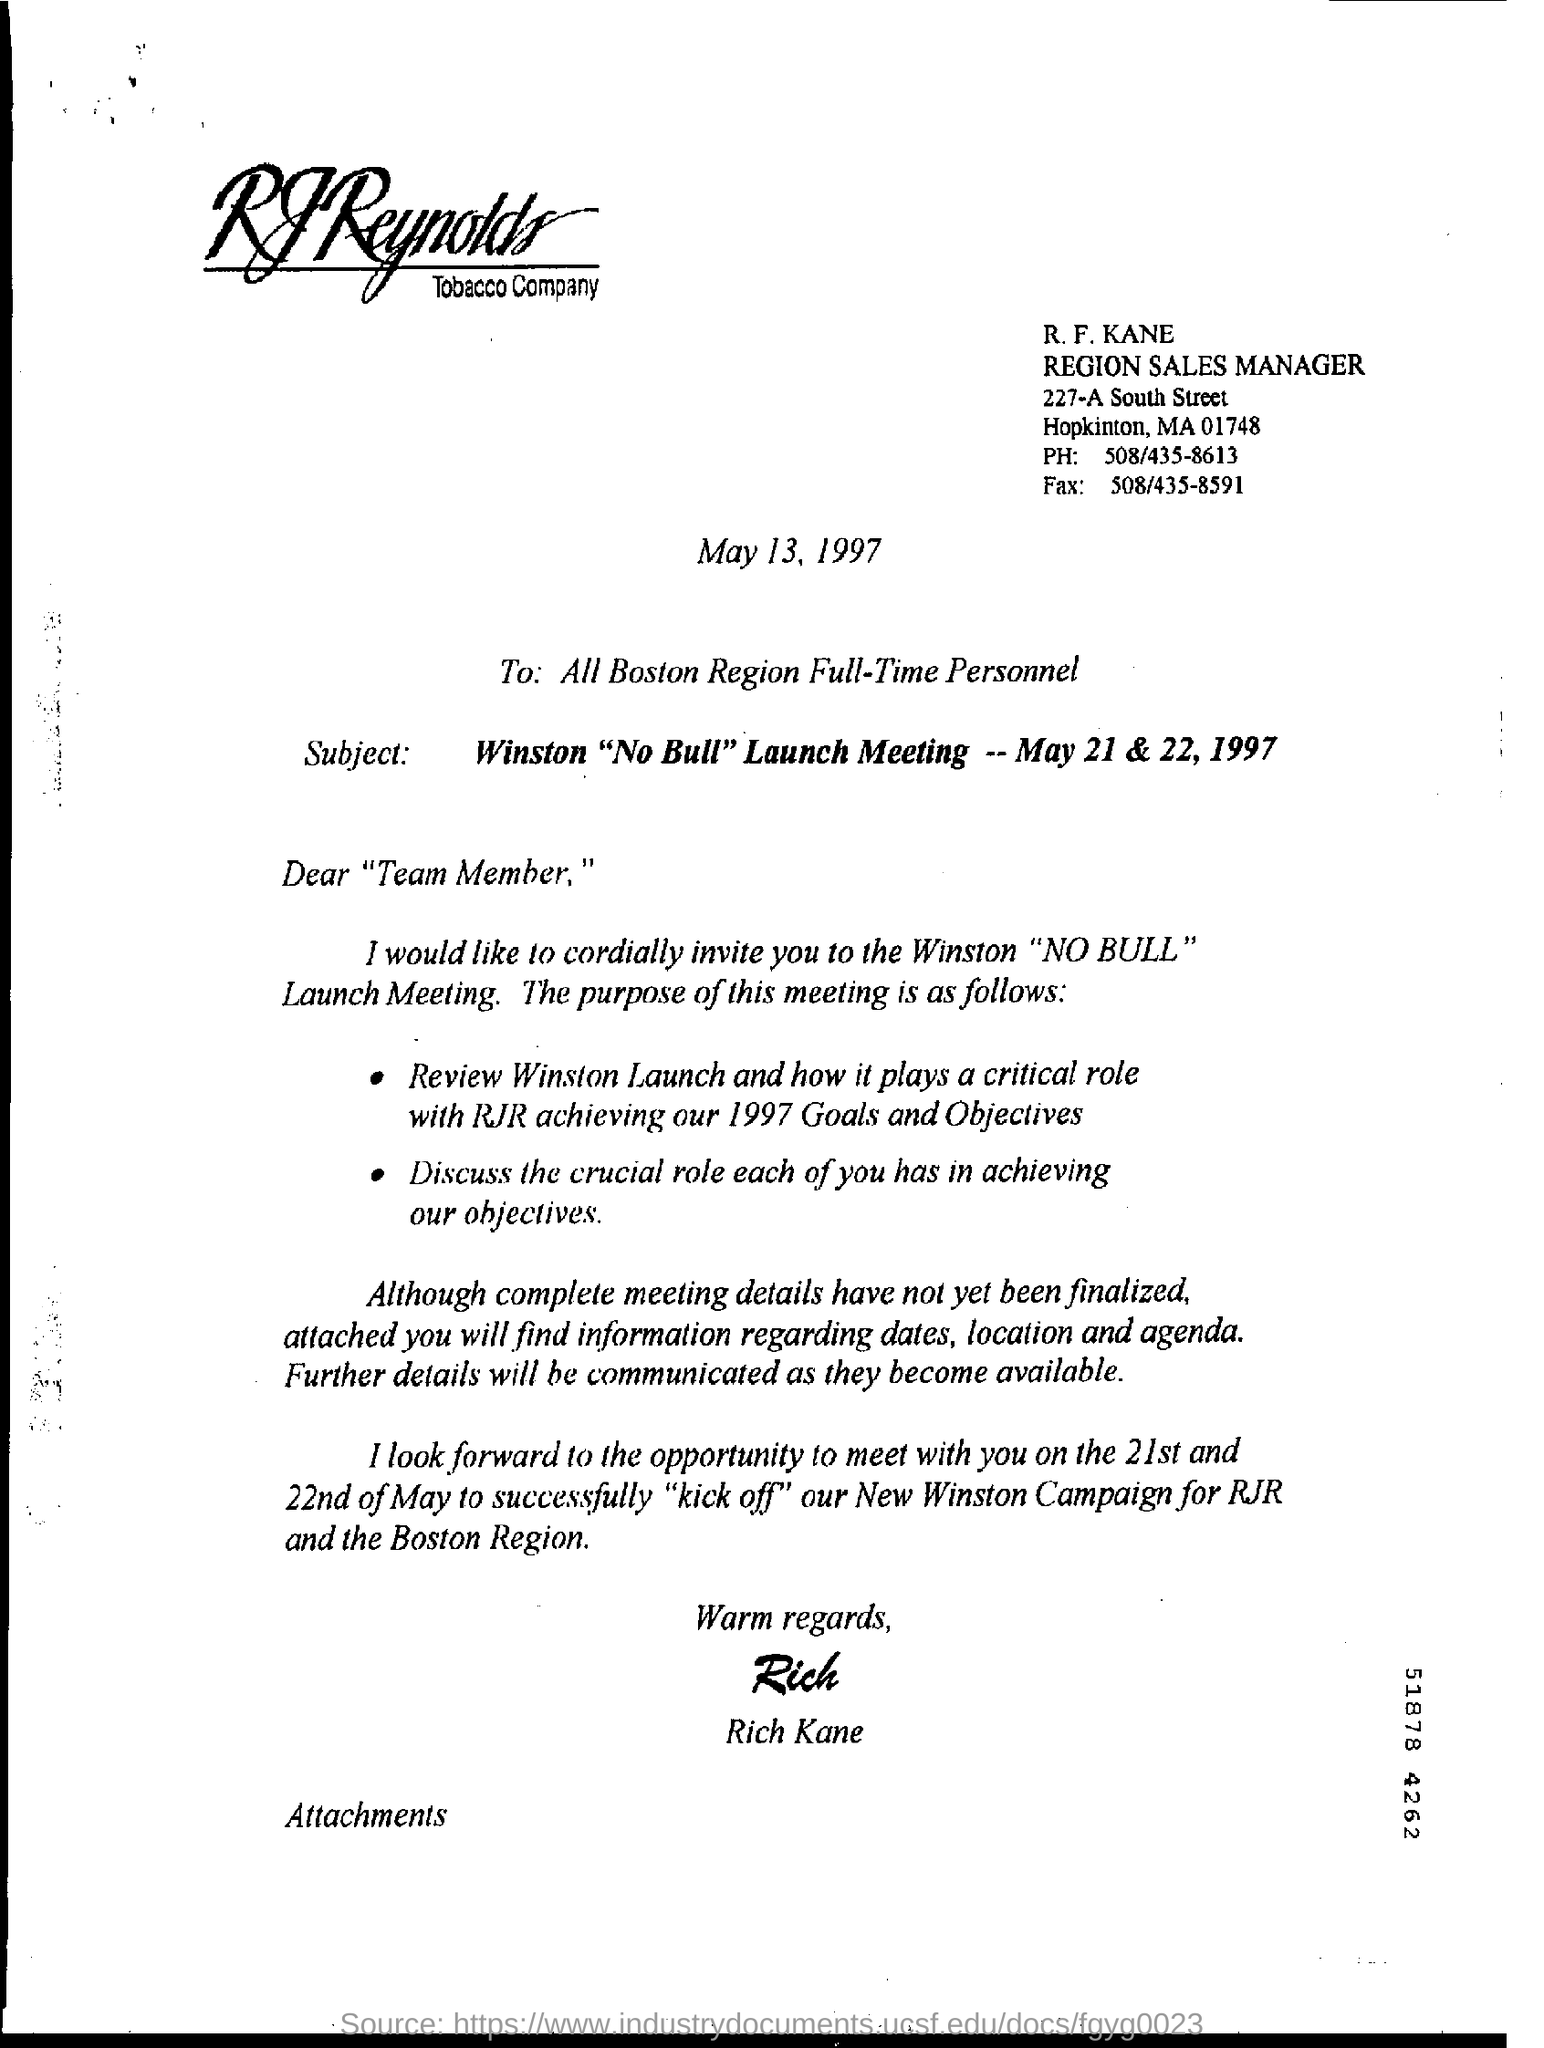What is the ph. no. mentioned ?
Provide a short and direct response. 508/435-8613. What is the fax no. mentioned ?
Make the answer very short. 508/435-8591. 